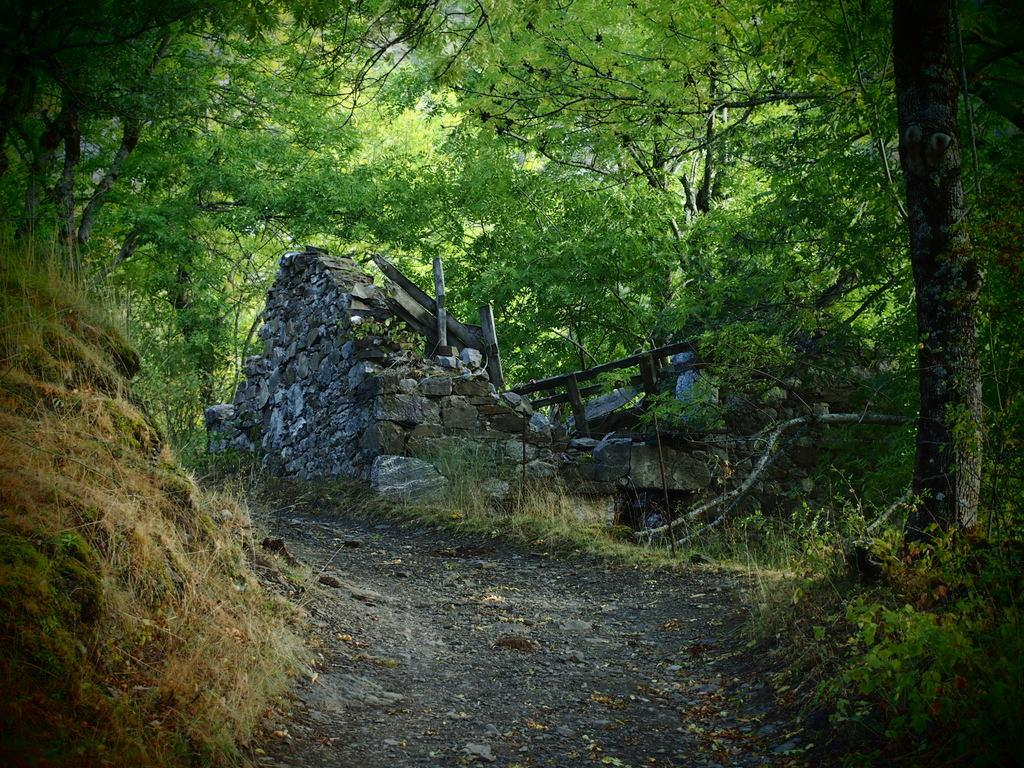What is the main feature in the center of the image? There is a road in the center of the image. What type of vegetation can be seen on both sides of the road? There is grass on both the right and left sides of the image. What can be seen in the background of the image? There are rocks and trees in the background of the image. What type of wing can be seen on the bird flying in the image? There are no birds or wings present in the image. What direction is the basket facing in the image? There is no basket present in the image. 